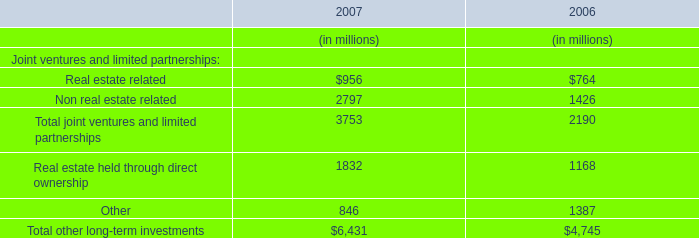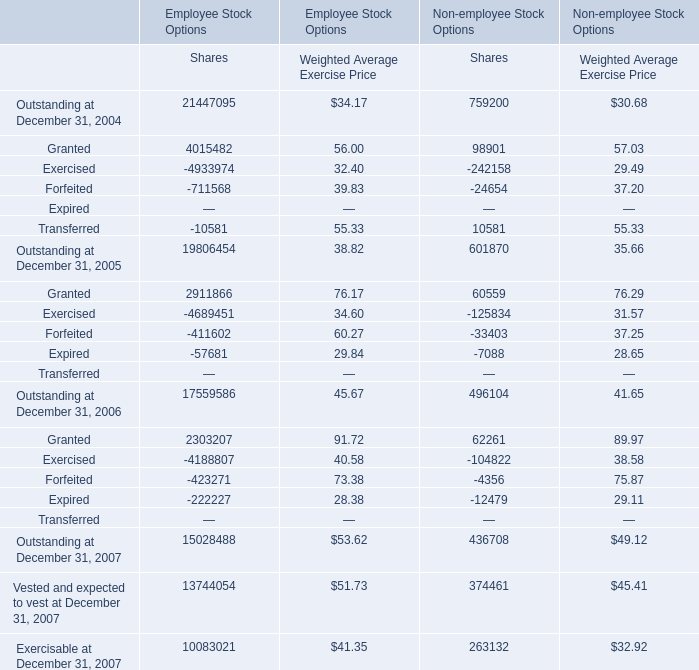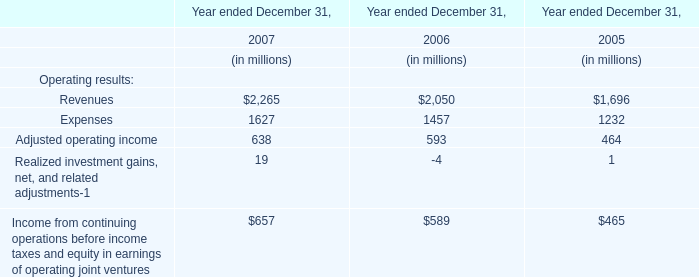What is the sum of Granted, Exercised and Forfeited in 2004 forWeighted Average Exercise Price for Employee Stock Options? 
Computations: ((56.00 + 32.40) + 39.83)
Answer: 128.23. 